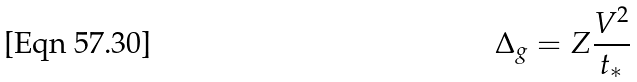<formula> <loc_0><loc_0><loc_500><loc_500>\Delta _ { g } = Z \frac { V ^ { 2 } } { t _ { * } }</formula> 